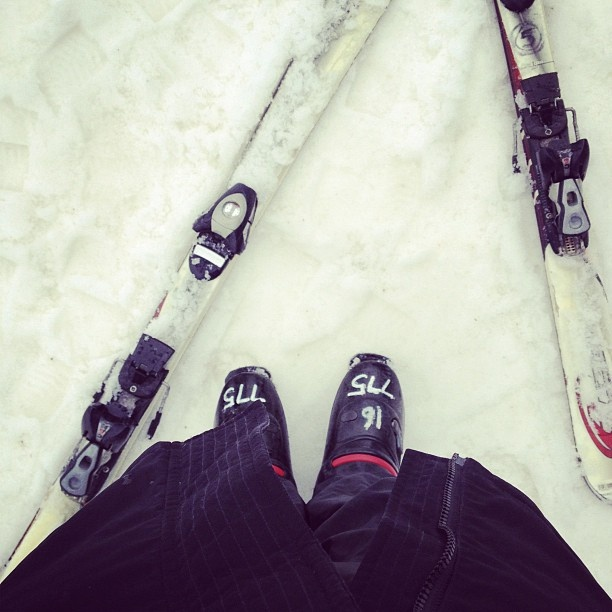Describe the objects in this image and their specific colors. I can see people in beige, black, and purple tones and skis in beige, darkgray, and black tones in this image. 